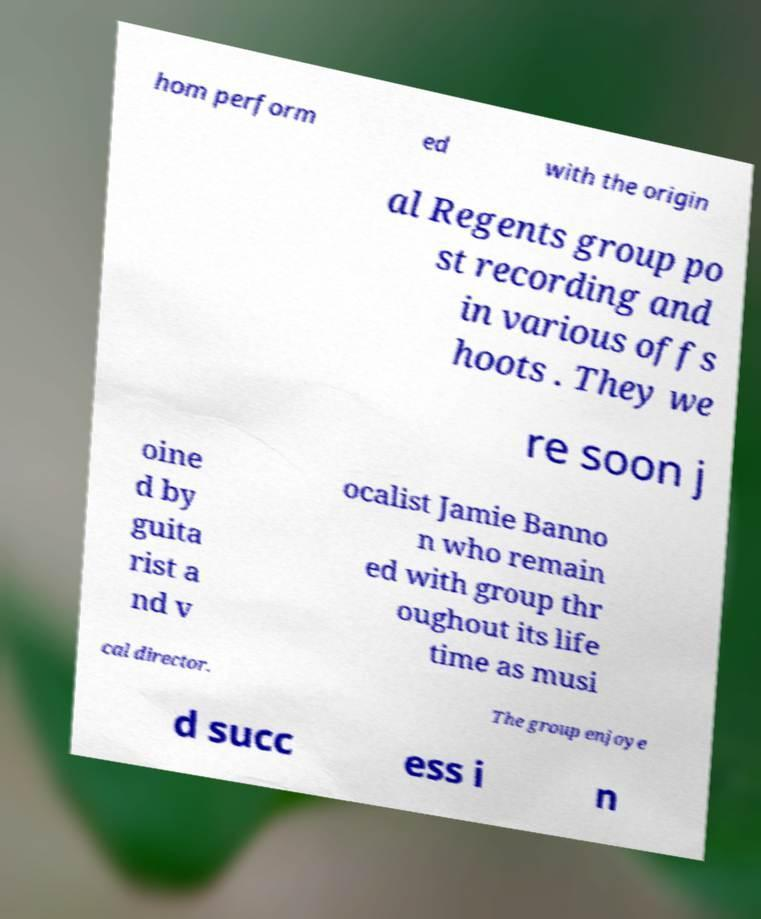Please read and relay the text visible in this image. What does it say? hom perform ed with the origin al Regents group po st recording and in various offs hoots . They we re soon j oine d by guita rist a nd v ocalist Jamie Banno n who remain ed with group thr oughout its life time as musi cal director. The group enjoye d succ ess i n 